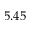<formula> <loc_0><loc_0><loc_500><loc_500>5 . 4 5</formula> 